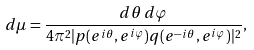Convert formula to latex. <formula><loc_0><loc_0><loc_500><loc_500>d \mu = \frac { d \theta \, d \varphi } { 4 \pi ^ { 2 } | p ( e ^ { i \theta } , e ^ { i \varphi } ) q ( e ^ { - i \theta } , e ^ { i \varphi } ) | ^ { 2 } } ,</formula> 